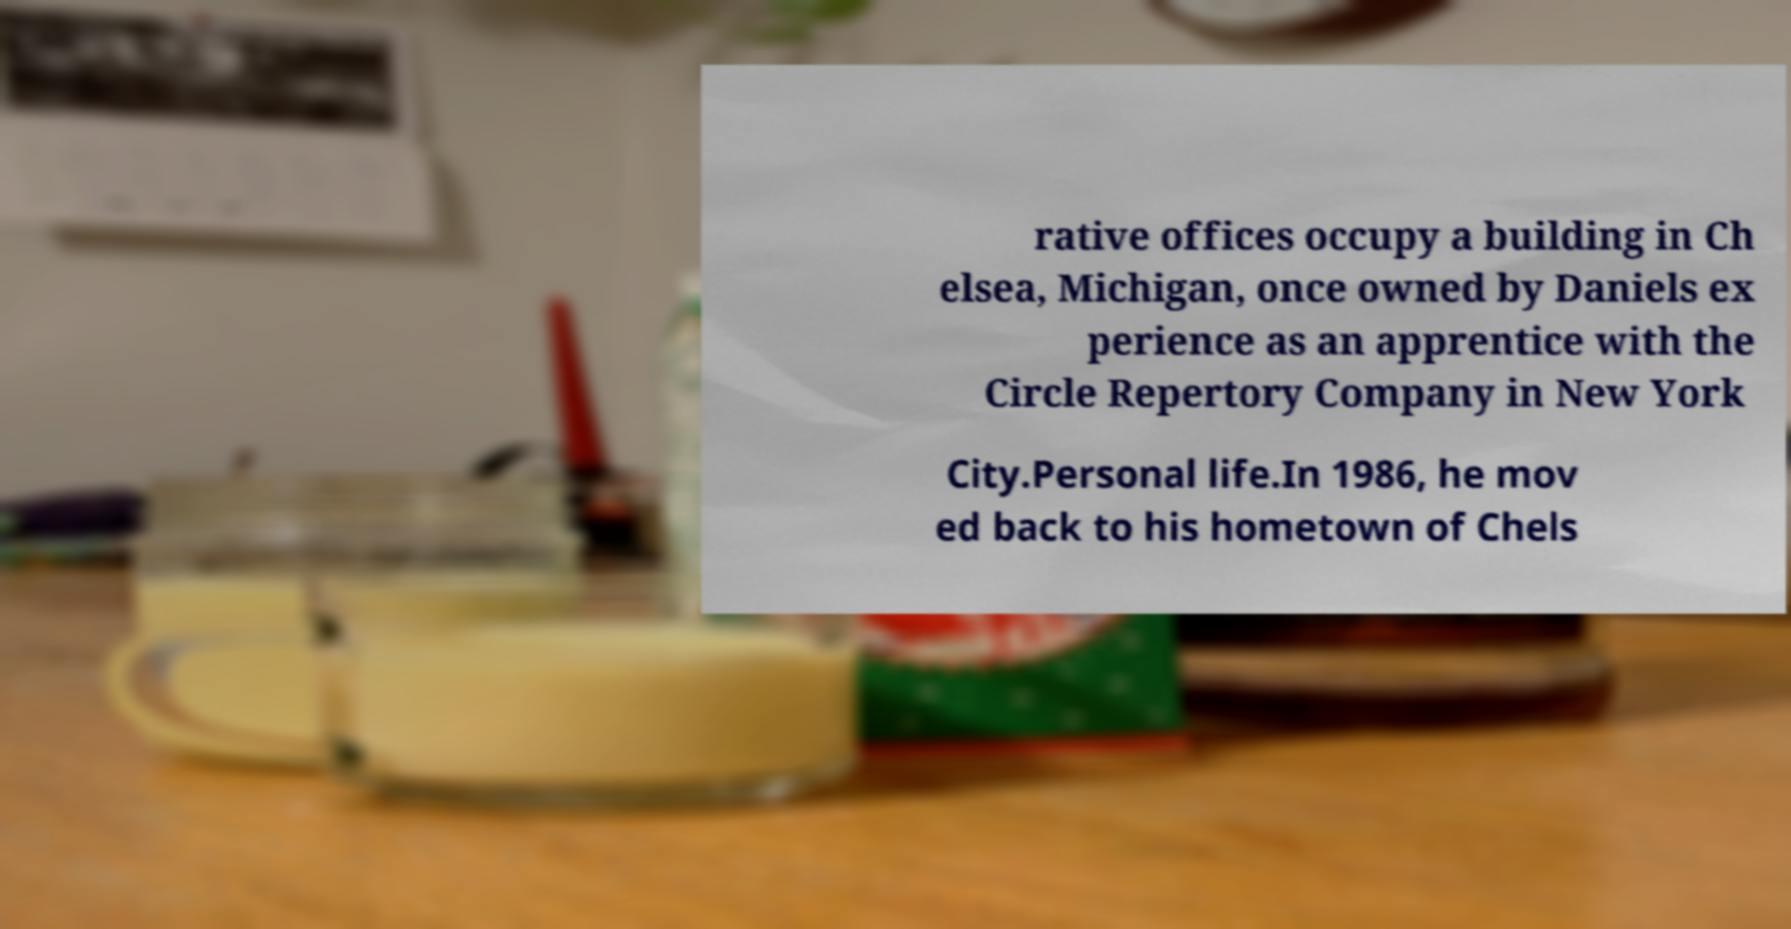Please read and relay the text visible in this image. What does it say? rative offices occupy a building in Ch elsea, Michigan, once owned by Daniels ex perience as an apprentice with the Circle Repertory Company in New York City.Personal life.In 1986, he mov ed back to his hometown of Chels 